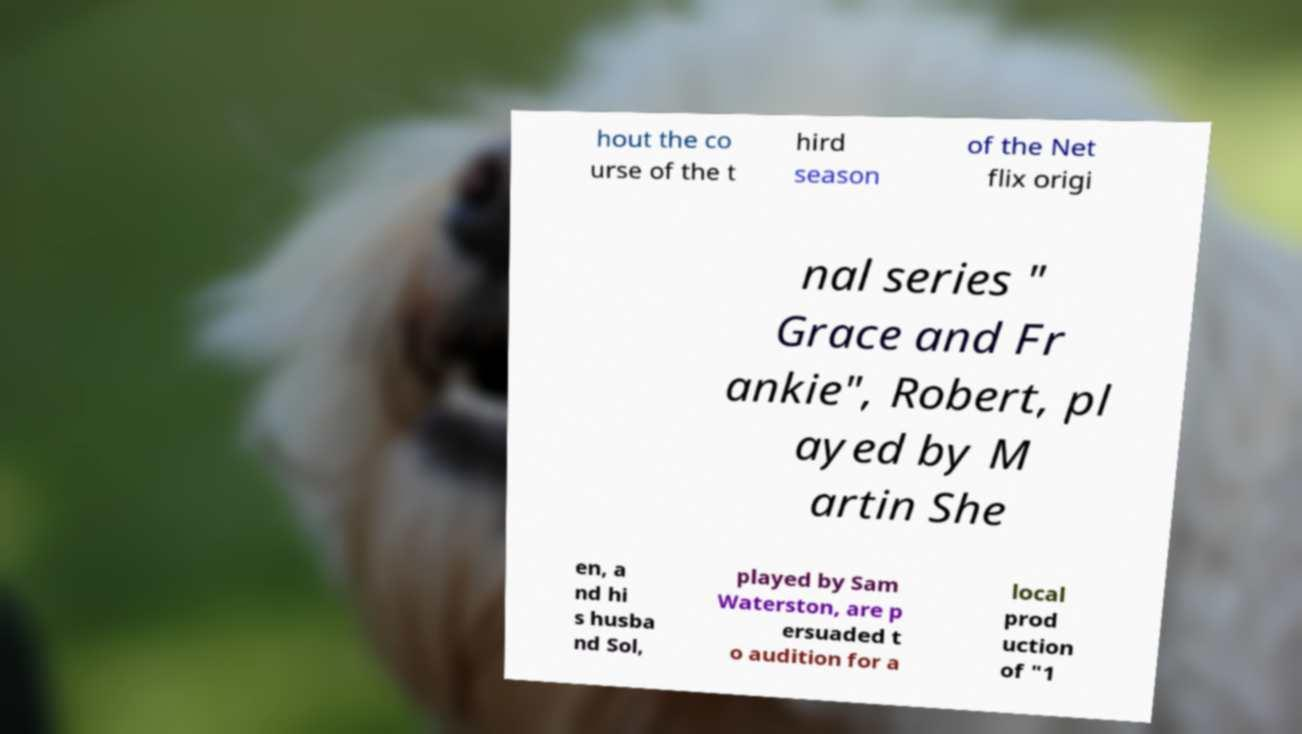Can you read and provide the text displayed in the image?This photo seems to have some interesting text. Can you extract and type it out for me? hout the co urse of the t hird season of the Net flix origi nal series " Grace and Fr ankie", Robert, pl ayed by M artin She en, a nd hi s husba nd Sol, played by Sam Waterston, are p ersuaded t o audition for a local prod uction of "1 